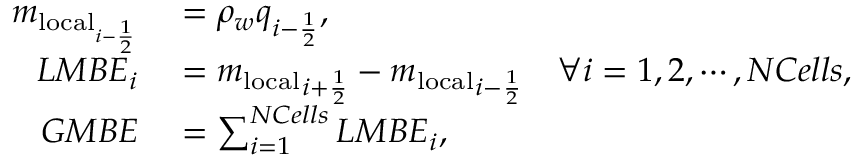Convert formula to latex. <formula><loc_0><loc_0><loc_500><loc_500>\begin{array} { r l } { m _ { l o c a l _ { i - \frac { 1 } { 2 } } } } & = \rho _ { w } q _ { i - \frac { 1 } { 2 } } , } \\ { L M B E _ { i } } & = { m _ { l o c a l } } _ { i + \frac { 1 } { 2 } } - { m _ { l o c a l } } _ { i - \frac { 1 } { 2 } } \quad \forall i = 1 , 2 , \cdots , N C e l l s , } \\ { G M B E } & = \sum _ { i = 1 } ^ { N C e l l s } L M B E _ { i } , } \end{array}</formula> 